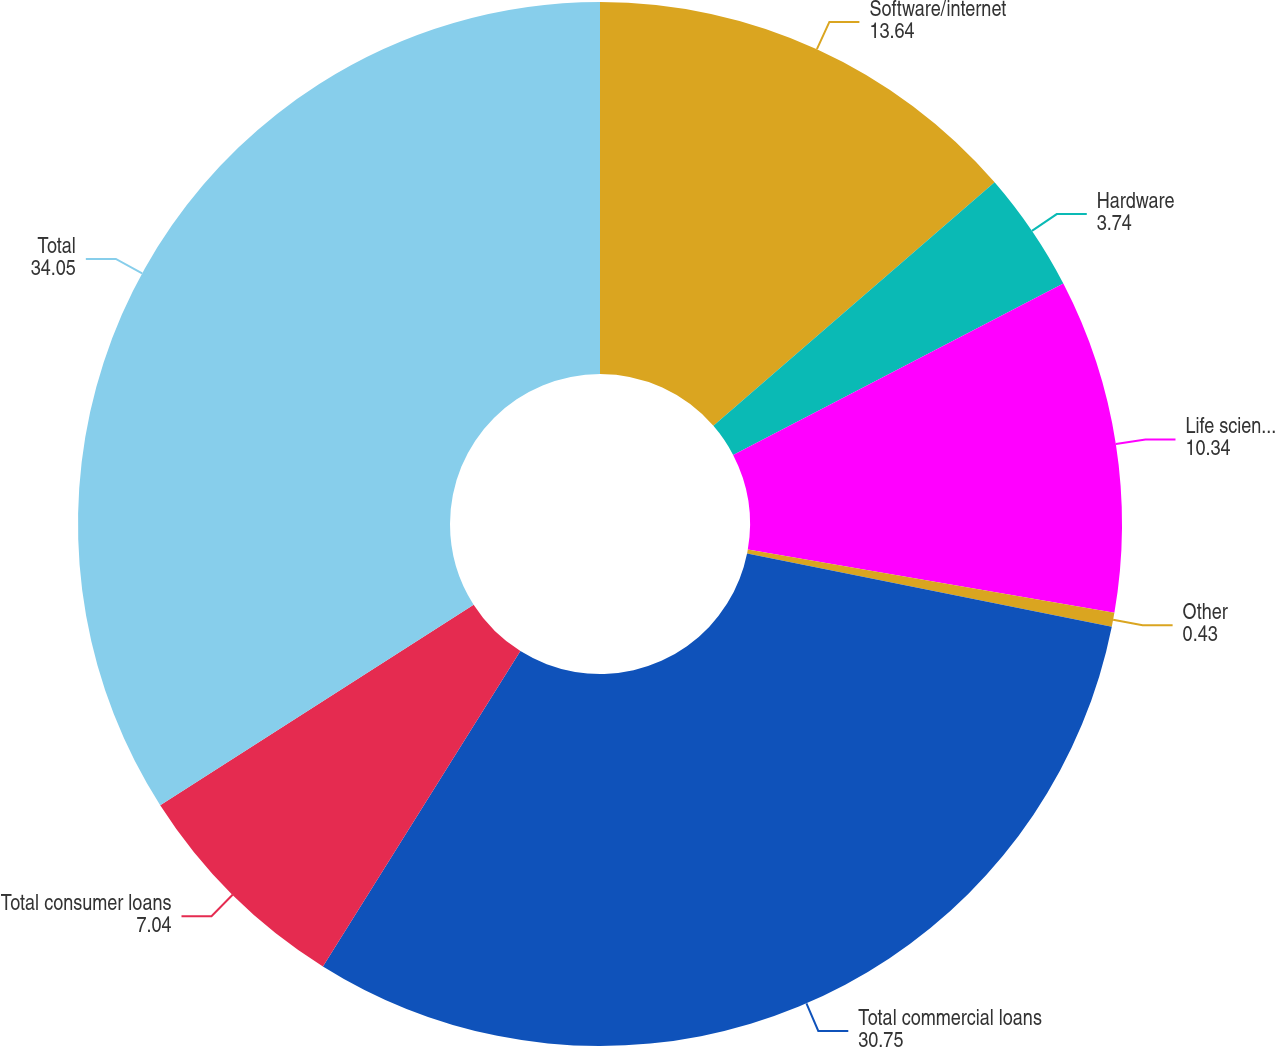<chart> <loc_0><loc_0><loc_500><loc_500><pie_chart><fcel>Software/internet<fcel>Hardware<fcel>Life science/healthcare<fcel>Other<fcel>Total commercial loans<fcel>Total consumer loans<fcel>Total<nl><fcel>13.64%<fcel>3.74%<fcel>10.34%<fcel>0.43%<fcel>30.75%<fcel>7.04%<fcel>34.05%<nl></chart> 